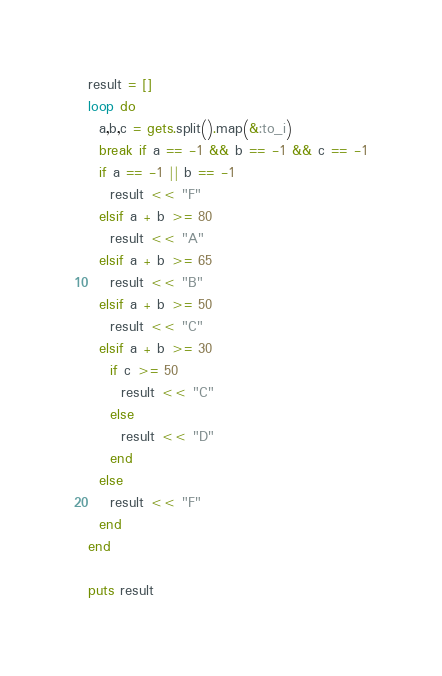<code> <loc_0><loc_0><loc_500><loc_500><_Ruby_>result = []
loop do
  a,b,c = gets.split().map(&:to_i)
  break if a == -1 && b == -1 && c == -1
  if a == -1 || b == -1
    result << "F"
  elsif a + b >= 80
    result << "A"
  elsif a + b >= 65
    result << "B"
  elsif a + b >= 50
    result << "C"
  elsif a + b >= 30
    if c >= 50
      result << "C"
    else
      result << "D"
    end
  else
    result << "F"
  end
end
  
puts result
</code> 